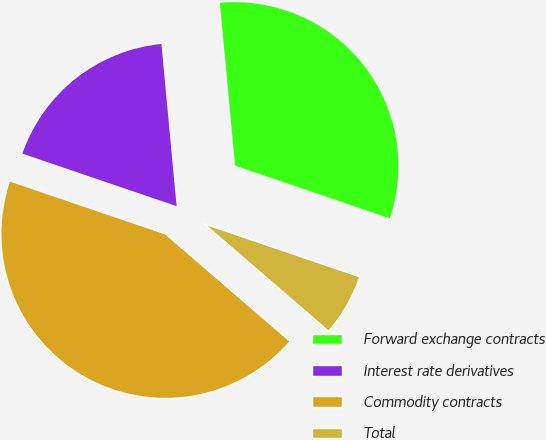Convert chart to OTSL. <chart><loc_0><loc_0><loc_500><loc_500><pie_chart><fcel>Forward exchange contracts<fcel>Interest rate derivatives<fcel>Commodity contracts<fcel>Total<nl><fcel>31.71%<fcel>18.29%<fcel>43.9%<fcel>6.1%<nl></chart> 